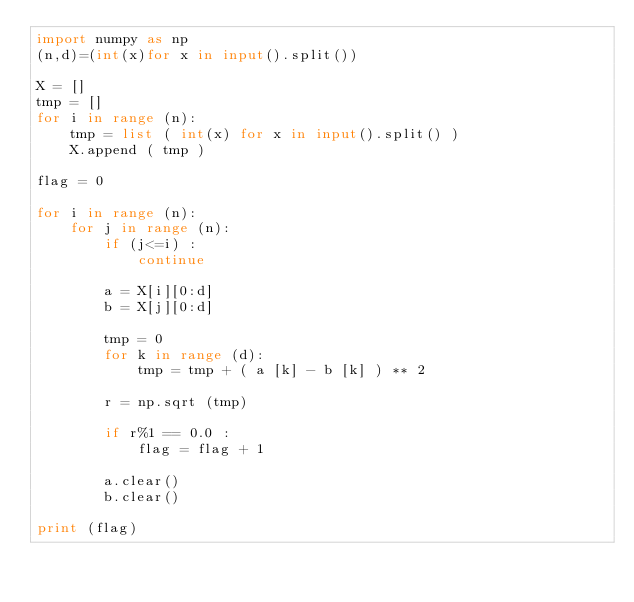<code> <loc_0><loc_0><loc_500><loc_500><_Python_>import numpy as np
(n,d)=(int(x)for x in input().split())

X = []
tmp = []
for i in range (n):    
    tmp = list ( int(x) for x in input().split() )
    X.append ( tmp )

flag = 0

for i in range (n):
    for j in range (n):  
        if (j<=i) :
            continue
        
        a = X[i][0:d]  
        b = X[j][0:d]

        tmp = 0
        for k in range (d):
            tmp = tmp + ( a [k] - b [k] ) ** 2
            
        r = np.sqrt (tmp)

        if r%1 == 0.0 :
            flag = flag + 1
            
        a.clear()
        b.clear()

print (flag)        
        
</code> 